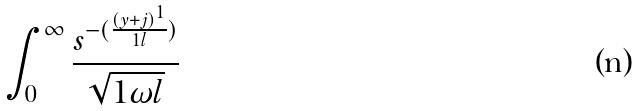<formula> <loc_0><loc_0><loc_500><loc_500>\int _ { 0 } ^ { \infty } \frac { s ^ { - ( \frac { ( y + j ) ^ { 1 } } { 1 l } ) } } { \sqrt { 1 \omega l } }</formula> 